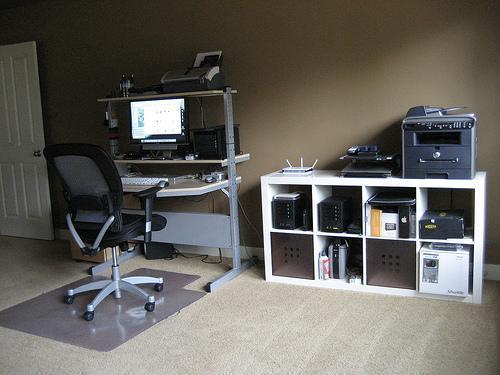How many printers do you see?
Give a very brief answer. 2. How many chairs are there?
Give a very brief answer. 1. How many screens does the computer have?
Give a very brief answer. 1. How many wheels does the chair have?
Give a very brief answer. 5. 